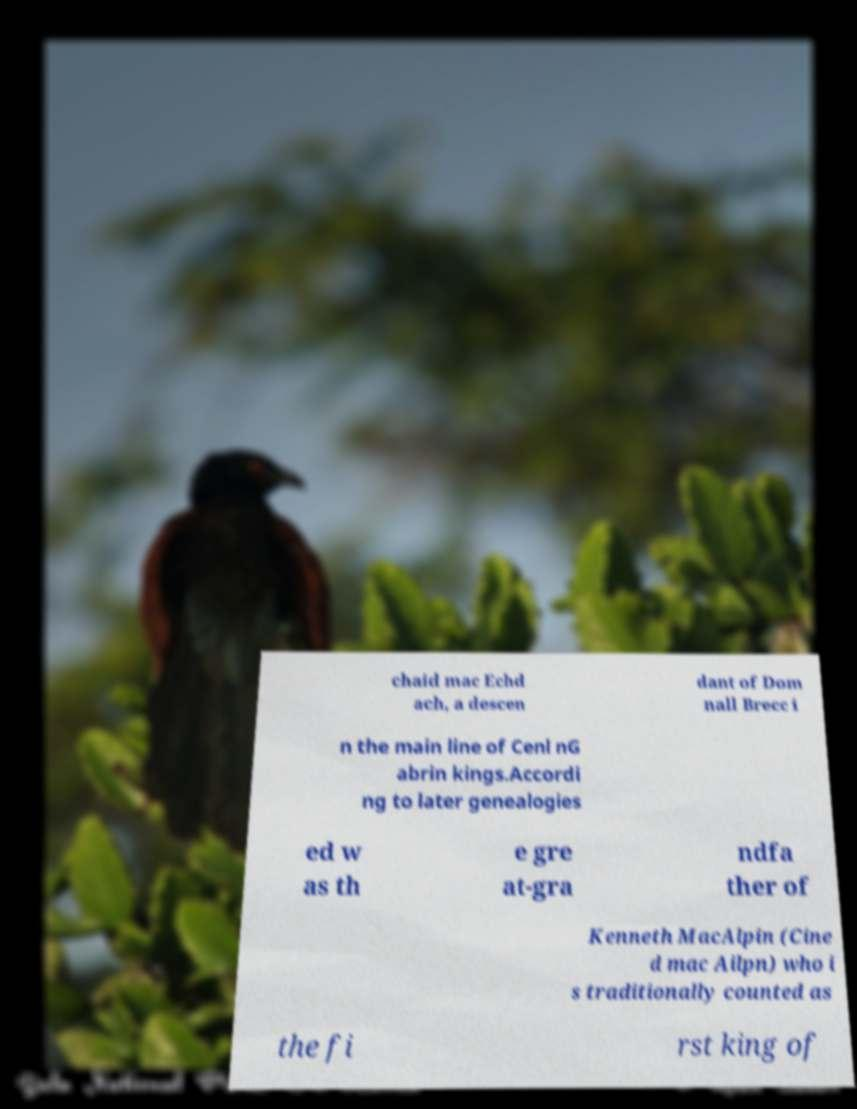For documentation purposes, I need the text within this image transcribed. Could you provide that? chaid mac Echd ach, a descen dant of Dom nall Brecc i n the main line of Cenl nG abrin kings.Accordi ng to later genealogies ed w as th e gre at-gra ndfa ther of Kenneth MacAlpin (Cine d mac Ailpn) who i s traditionally counted as the fi rst king of 